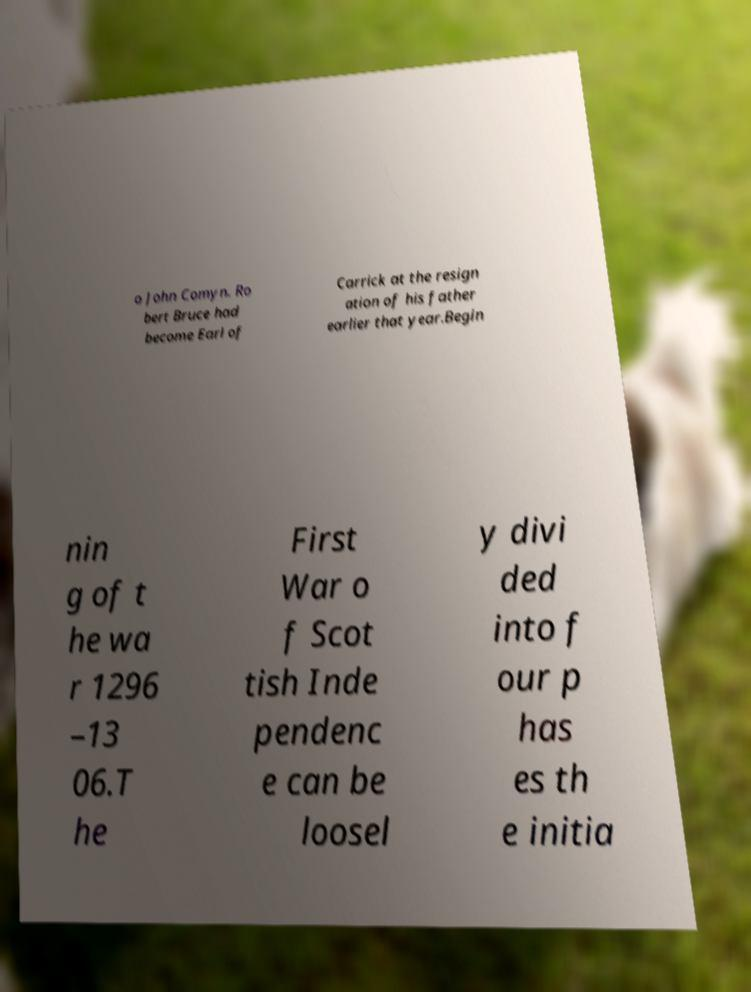Please identify and transcribe the text found in this image. o John Comyn. Ro bert Bruce had become Earl of Carrick at the resign ation of his father earlier that year.Begin nin g of t he wa r 1296 –13 06.T he First War o f Scot tish Inde pendenc e can be loosel y divi ded into f our p has es th e initia 